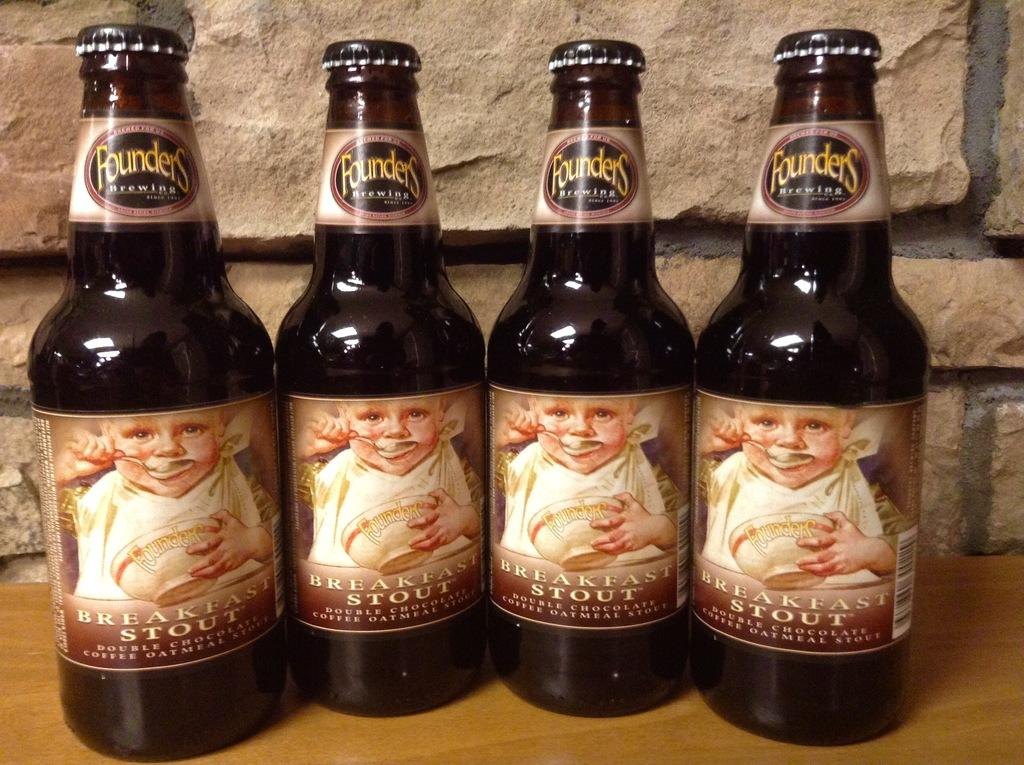<image>
Offer a succinct explanation of the picture presented. Four bottles of breakfast stout are lined up togetjer 